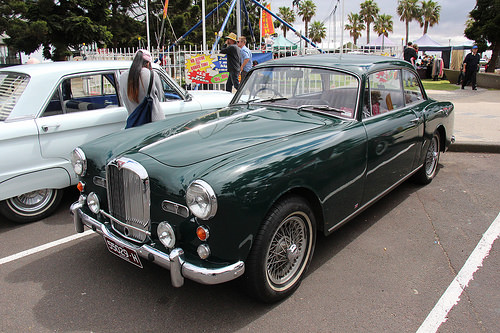<image>
Is the woman next to the car? Yes. The woman is positioned adjacent to the car, located nearby in the same general area. 